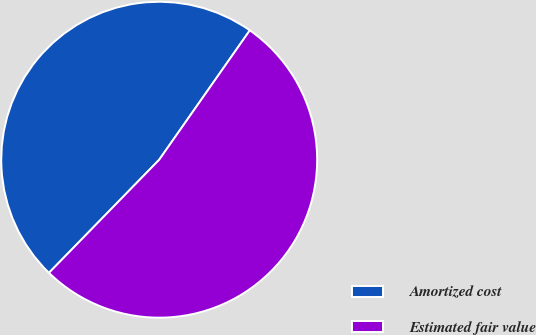<chart> <loc_0><loc_0><loc_500><loc_500><pie_chart><fcel>Amortized cost<fcel>Estimated fair value<nl><fcel>47.43%<fcel>52.57%<nl></chart> 